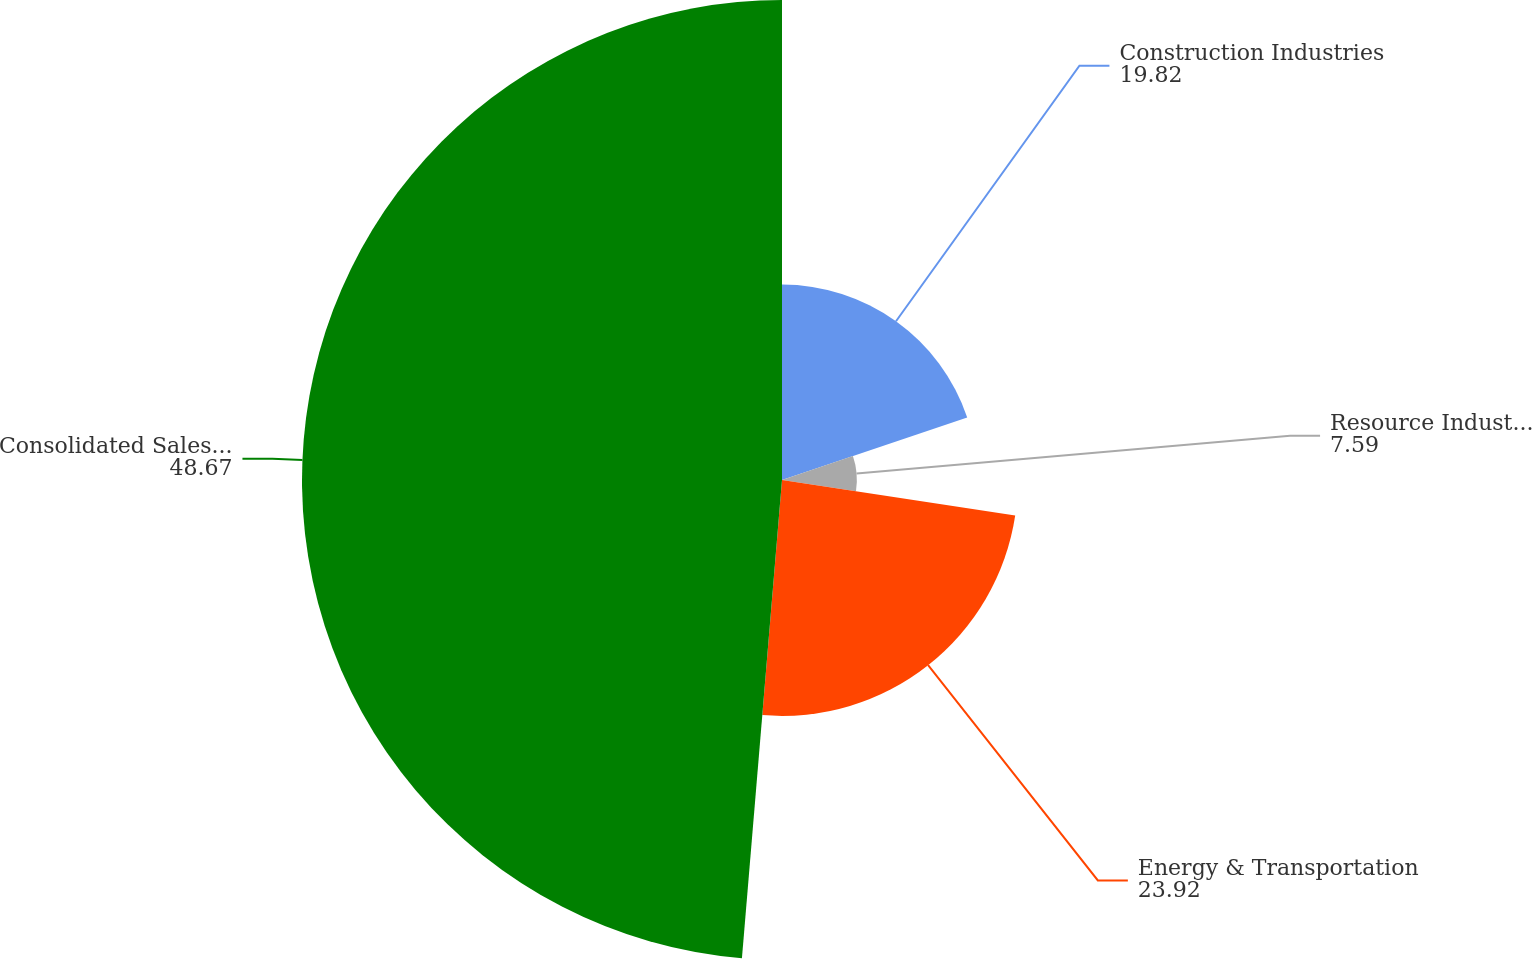<chart> <loc_0><loc_0><loc_500><loc_500><pie_chart><fcel>Construction Industries<fcel>Resource Industries<fcel>Energy & Transportation<fcel>Consolidated Sales and<nl><fcel>19.82%<fcel>7.59%<fcel>23.92%<fcel>48.67%<nl></chart> 